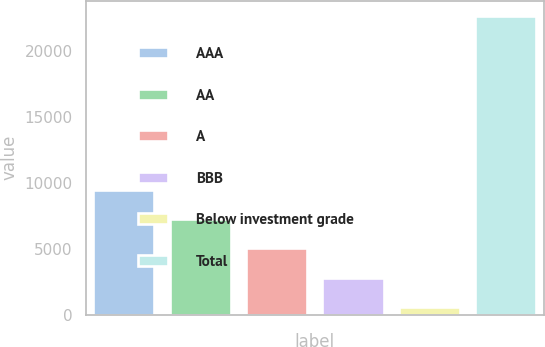Convert chart to OTSL. <chart><loc_0><loc_0><loc_500><loc_500><bar_chart><fcel>AAA<fcel>AA<fcel>A<fcel>BBB<fcel>Below investment grade<fcel>Total<nl><fcel>9451<fcel>7244<fcel>5014<fcel>2807<fcel>600<fcel>22670<nl></chart> 